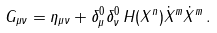<formula> <loc_0><loc_0><loc_500><loc_500>G _ { \mu \nu } = \eta _ { \mu \nu } + \delta ^ { 0 } _ { \mu } \delta ^ { 0 } _ { \nu } \, H ( X ^ { n } ) \dot { X } ^ { m } \dot { X } ^ { m } \, .</formula> 